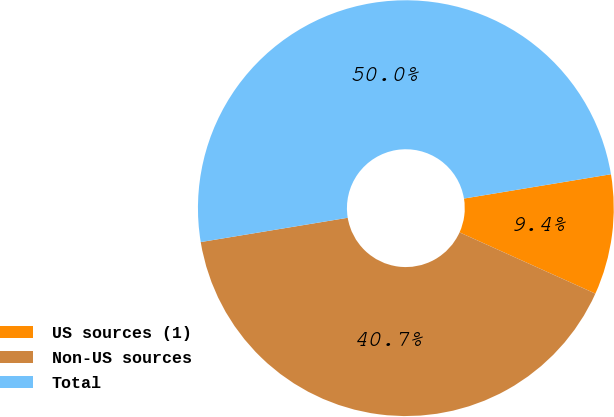<chart> <loc_0><loc_0><loc_500><loc_500><pie_chart><fcel>US sources (1)<fcel>Non-US sources<fcel>Total<nl><fcel>9.35%<fcel>40.65%<fcel>50.0%<nl></chart> 